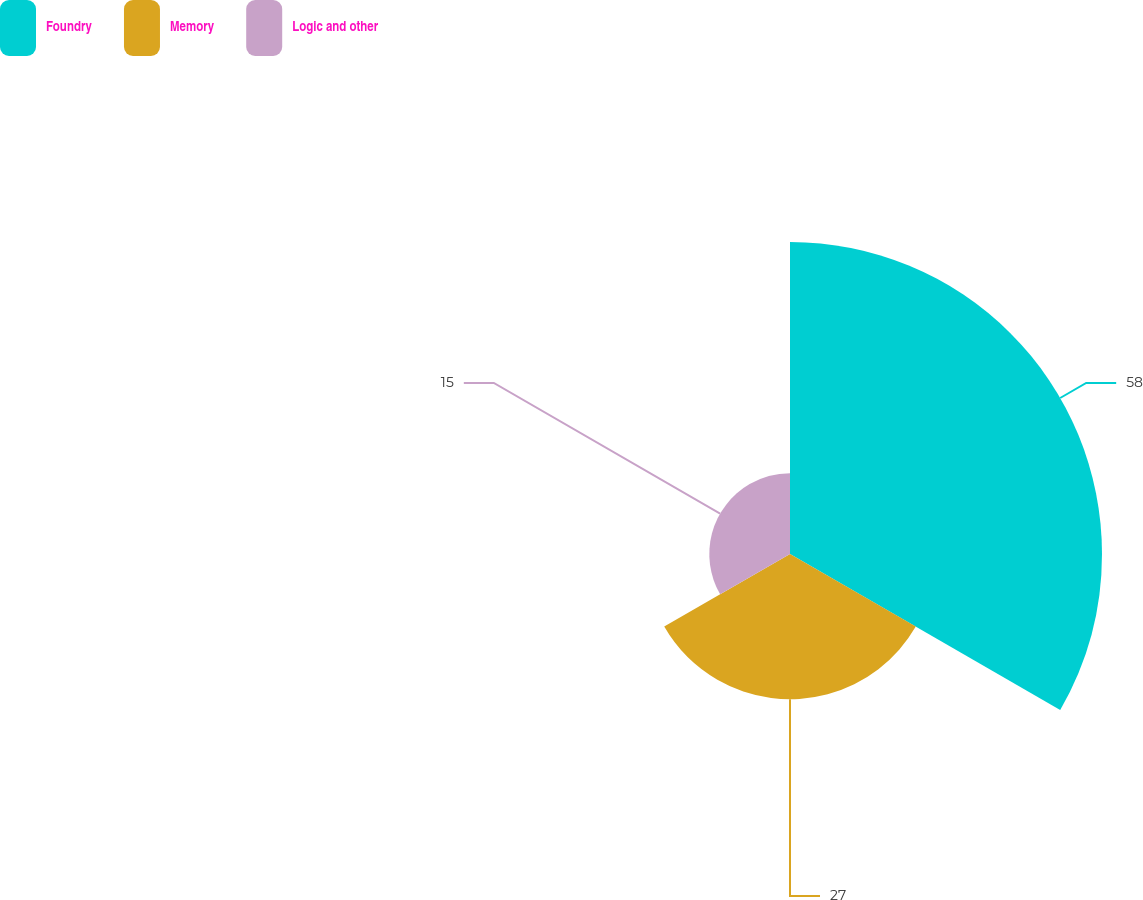<chart> <loc_0><loc_0><loc_500><loc_500><pie_chart><fcel>Foundry<fcel>Memory<fcel>Logic and other<nl><fcel>58.0%<fcel>27.0%<fcel>15.0%<nl></chart> 